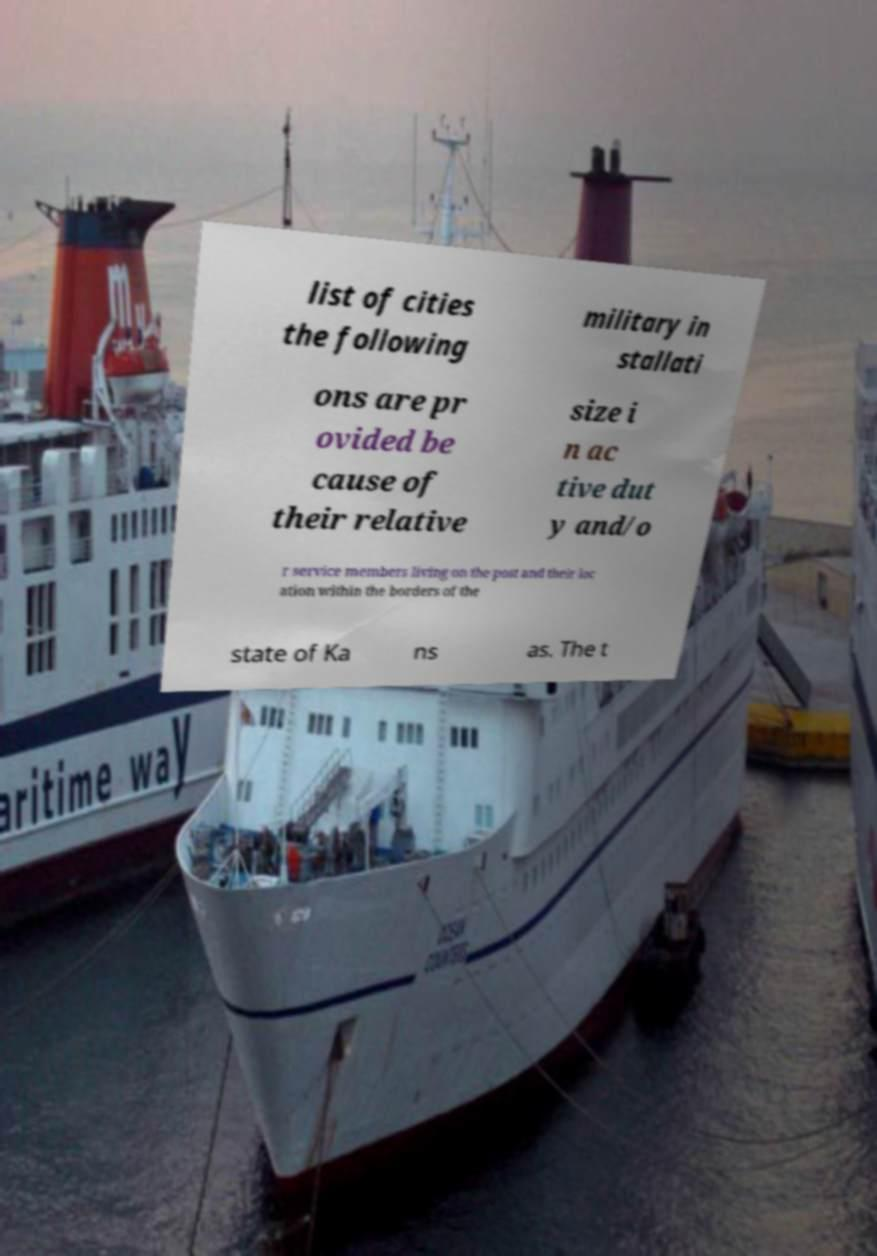Can you accurately transcribe the text from the provided image for me? list of cities the following military in stallati ons are pr ovided be cause of their relative size i n ac tive dut y and/o r service members living on the post and their loc ation within the borders of the state of Ka ns as. The t 